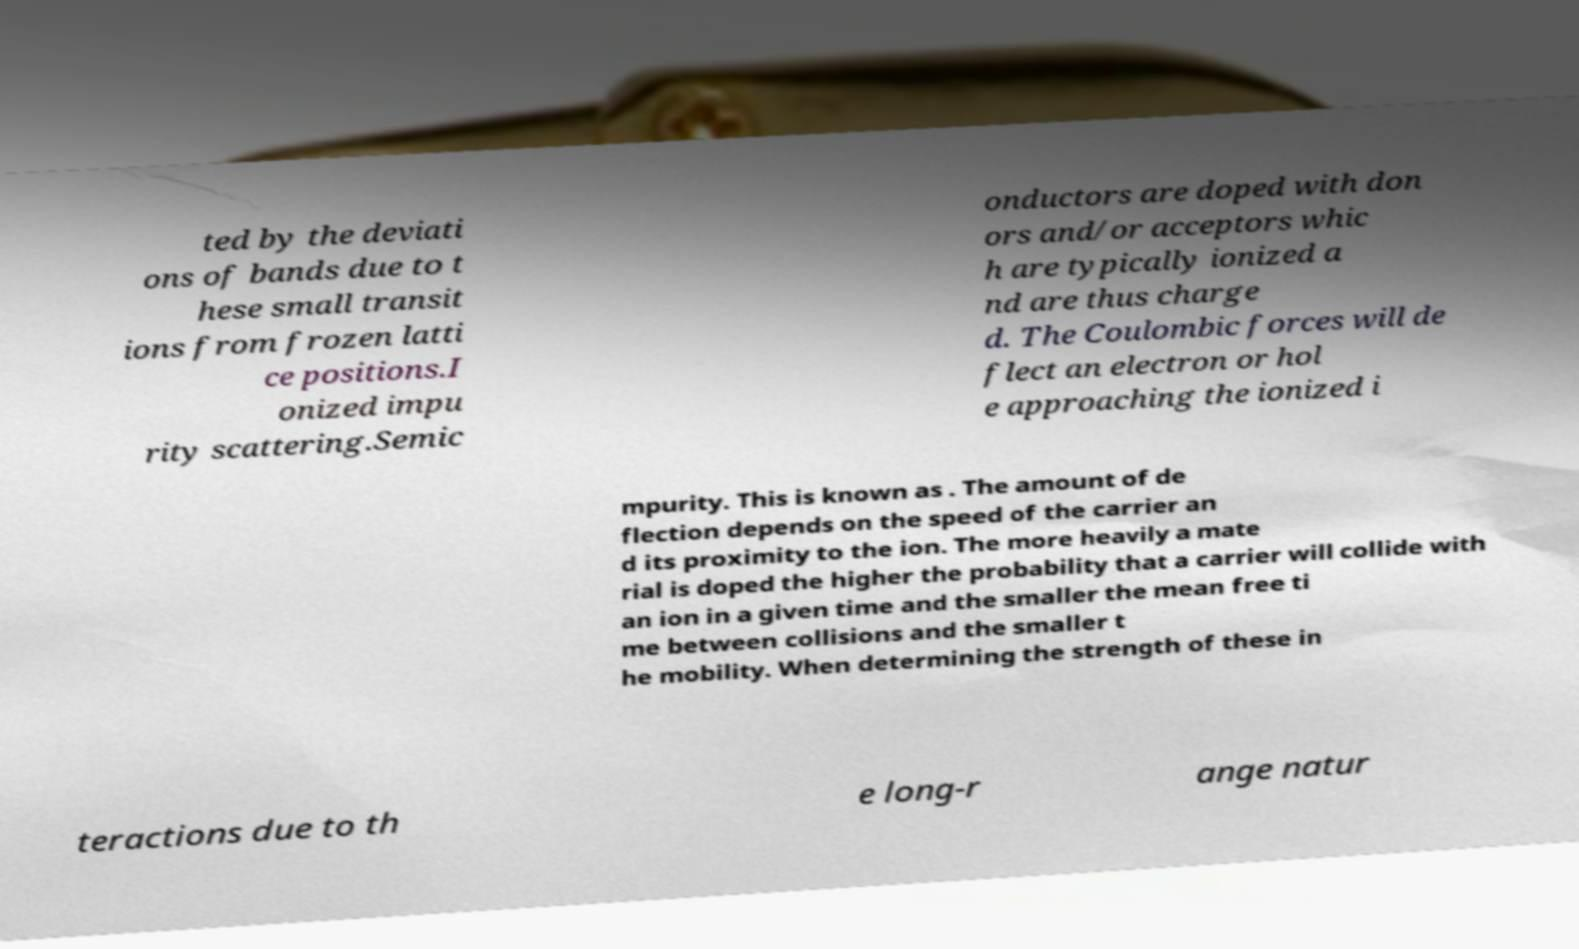I need the written content from this picture converted into text. Can you do that? ted by the deviati ons of bands due to t hese small transit ions from frozen latti ce positions.I onized impu rity scattering.Semic onductors are doped with don ors and/or acceptors whic h are typically ionized a nd are thus charge d. The Coulombic forces will de flect an electron or hol e approaching the ionized i mpurity. This is known as . The amount of de flection depends on the speed of the carrier an d its proximity to the ion. The more heavily a mate rial is doped the higher the probability that a carrier will collide with an ion in a given time and the smaller the mean free ti me between collisions and the smaller t he mobility. When determining the strength of these in teractions due to th e long-r ange natur 